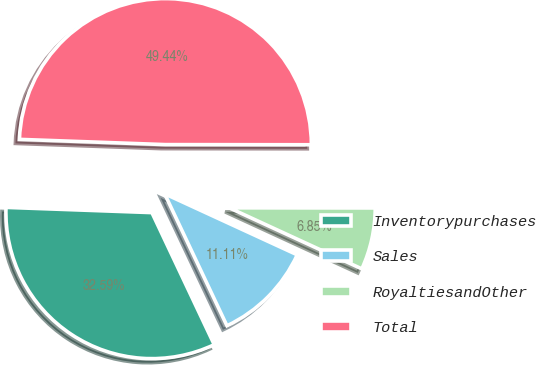<chart> <loc_0><loc_0><loc_500><loc_500><pie_chart><fcel>Inventorypurchases<fcel>Sales<fcel>RoyaltiesandOther<fcel>Total<nl><fcel>32.59%<fcel>11.11%<fcel>6.85%<fcel>49.44%<nl></chart> 